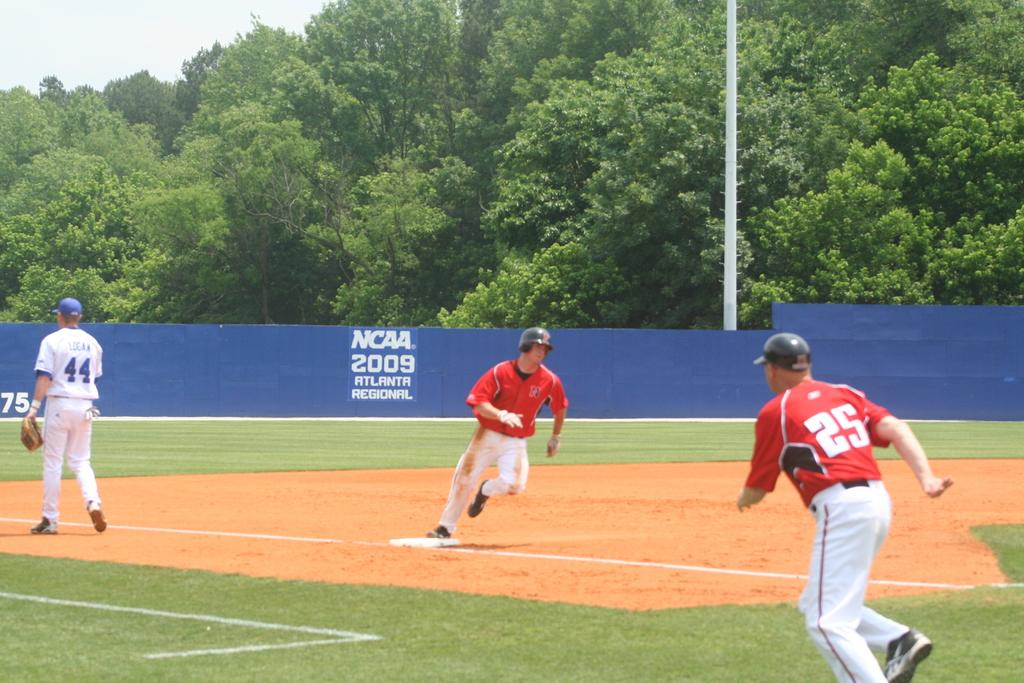<image>
Present a compact description of the photo's key features. Players run around the bases at the NCAA 2049 Atlanta Regional game. 